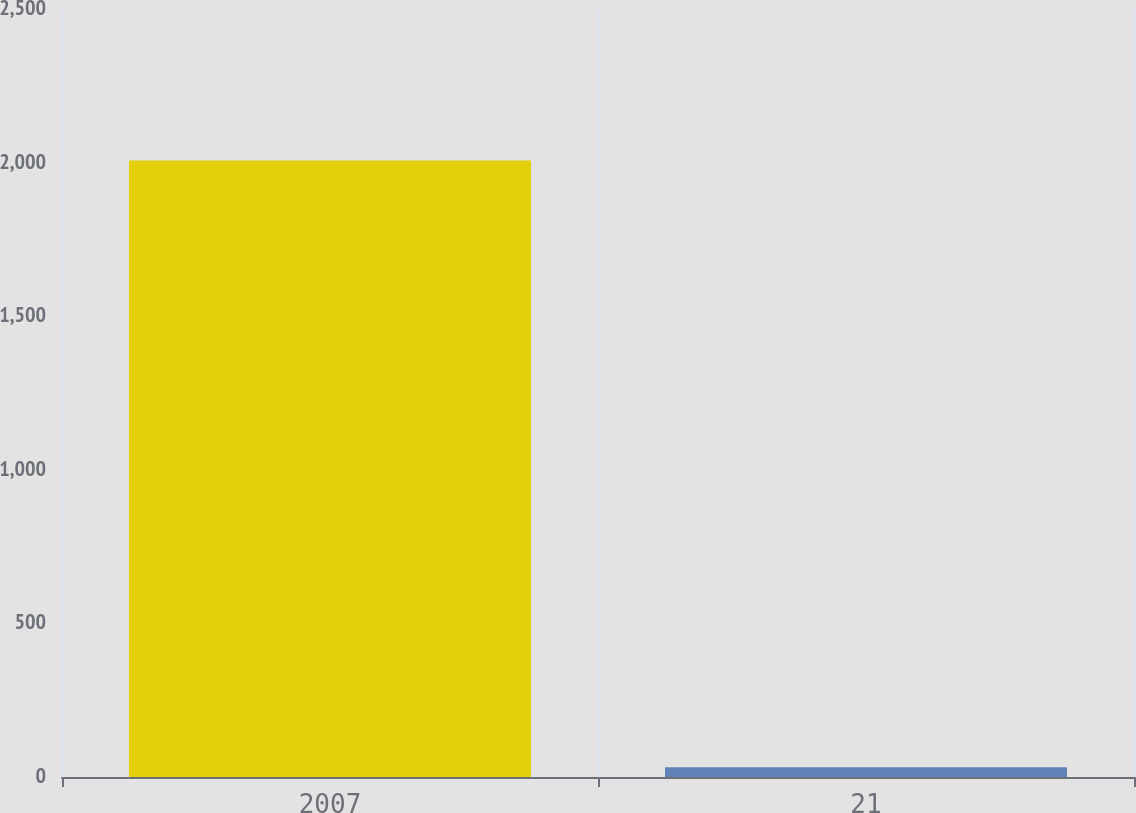Convert chart. <chart><loc_0><loc_0><loc_500><loc_500><bar_chart><fcel>2007<fcel>21<nl><fcel>2007<fcel>32<nl></chart> 